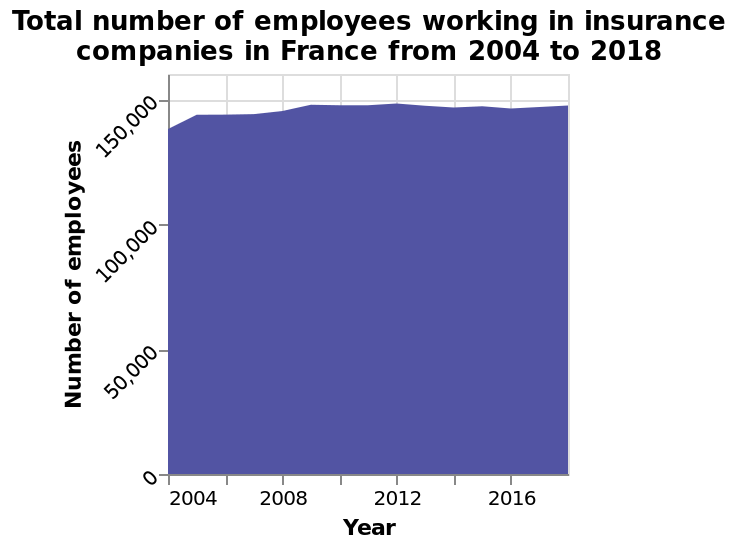<image>
How many people were working in insurance in France from 2009 to 2018? The number of people working in insurance in France has stayed consistent at around 150,000 people from 2009 to 2018. 